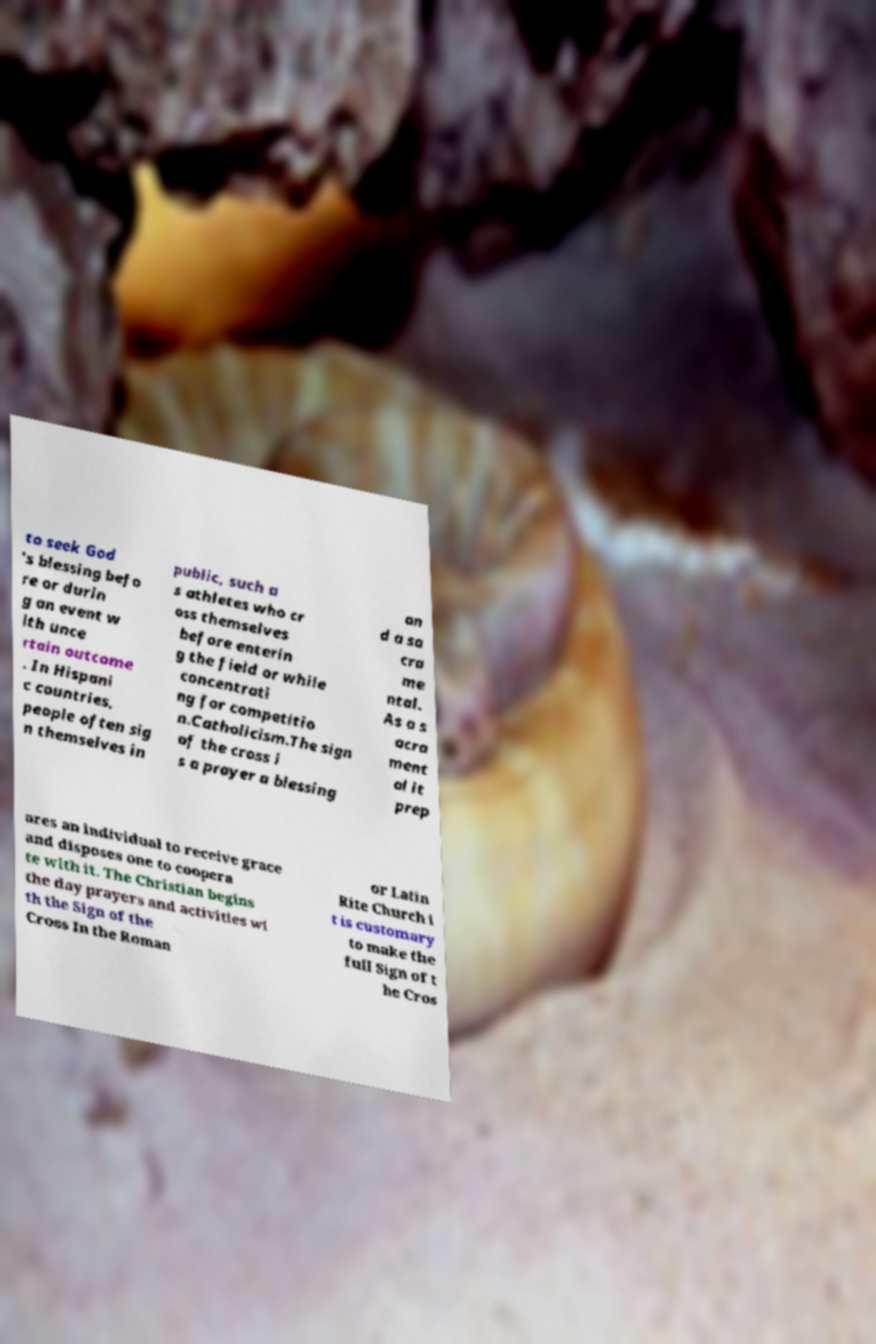Could you assist in decoding the text presented in this image and type it out clearly? to seek God 's blessing befo re or durin g an event w ith unce rtain outcome . In Hispani c countries, people often sig n themselves in public, such a s athletes who cr oss themselves before enterin g the field or while concentrati ng for competitio n.Catholicism.The sign of the cross i s a prayer a blessing an d a sa cra me ntal. As a s acra ment al it prep ares an individual to receive grace and disposes one to coopera te with it. The Christian begins the day prayers and activities wi th the Sign of the Cross In the Roman or Latin Rite Church i t is customary to make the full Sign of t he Cros 